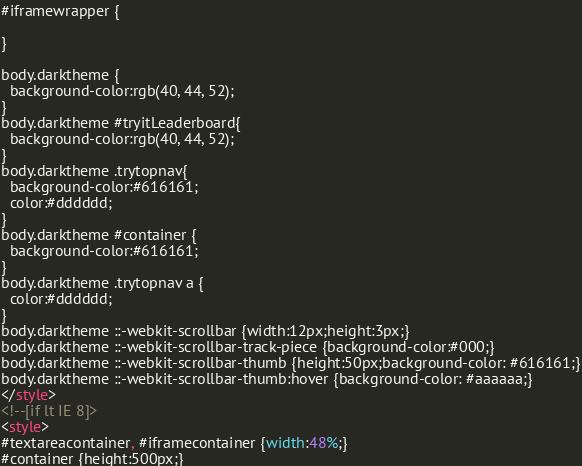<code> <loc_0><loc_0><loc_500><loc_500><_HTML_>#iframewrapper {
	
}

body.darktheme {
  background-color:rgb(40, 44, 52);
}
body.darktheme #tryitLeaderboard{
  background-color:rgb(40, 44, 52);
}
body.darktheme .trytopnav{
  background-color:#616161;
  color:#dddddd;
}
body.darktheme #container {
  background-color:#616161;
}
body.darktheme .trytopnav a {
  color:#dddddd;
}
body.darktheme ::-webkit-scrollbar {width:12px;height:3px;}
body.darktheme ::-webkit-scrollbar-track-piece {background-color:#000;}
body.darktheme ::-webkit-scrollbar-thumb {height:50px;background-color: #616161;}
body.darktheme ::-webkit-scrollbar-thumb:hover {background-color: #aaaaaa;}
</style>
<!--[if lt IE 8]>
<style>
#textareacontainer, #iframecontainer {width:48%;}
#container {height:500px;}</code> 